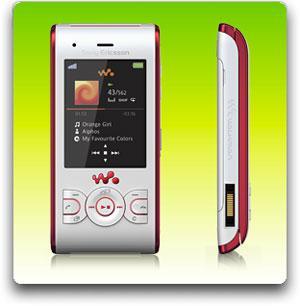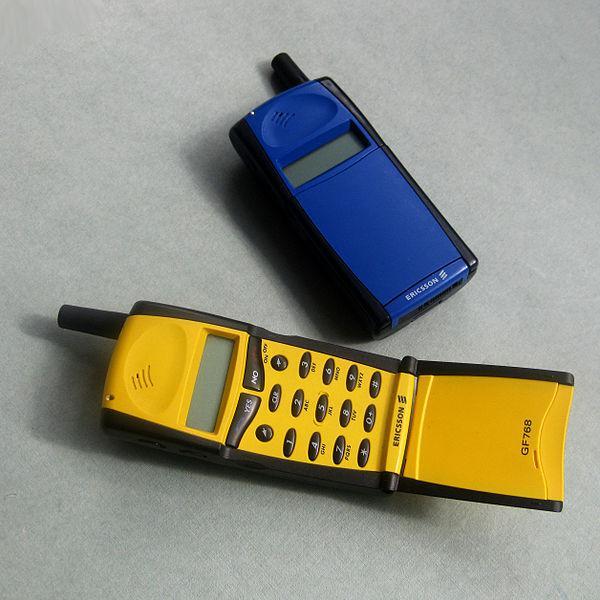The first image is the image on the left, the second image is the image on the right. For the images displayed, is the sentence "The phone in the image on the right is in the slide out position." factually correct? Answer yes or no. No. The first image is the image on the left, the second image is the image on the right. Assess this claim about the two images: "Each image contains one device, each device has a vertical rectangular screen, and one device is shown with its front sliding up to reveal the key pad.". Correct or not? Answer yes or no. No. 